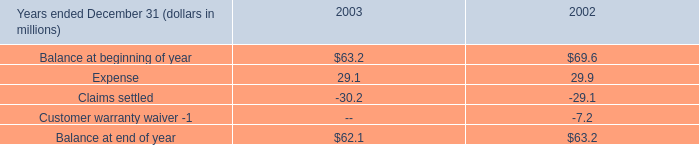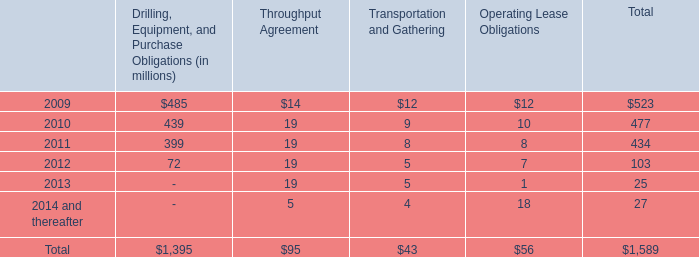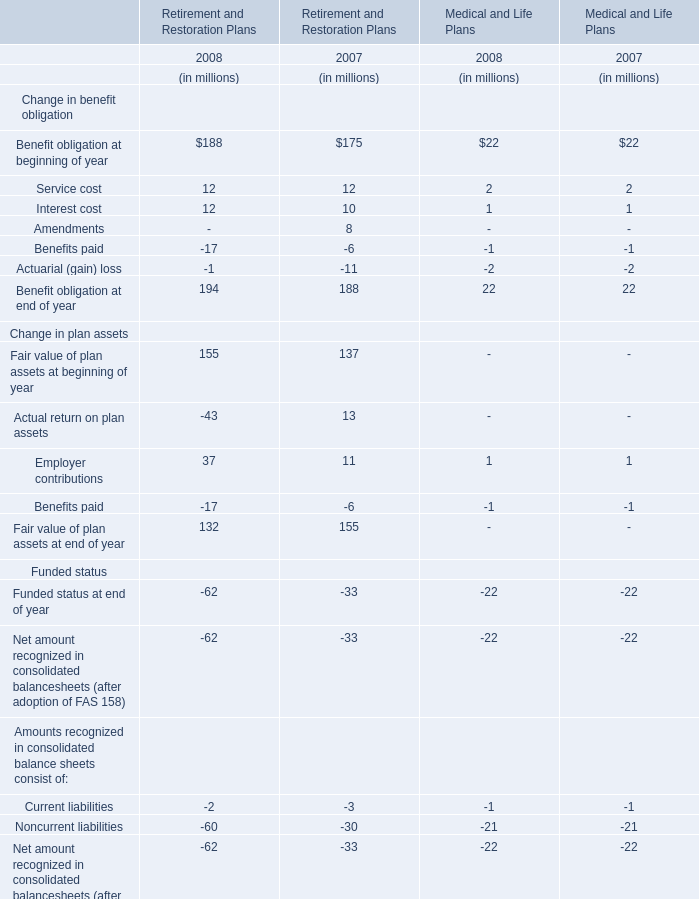What's the total amount of the Benefit obligation for Retirement and Restoration Plans in the years where Employer contributions for Retirement and Restoration Plans is greater than 30? (in million) 
Computations: ((((188 + 12) + 12) - 17) - 1)
Answer: 194.0. 